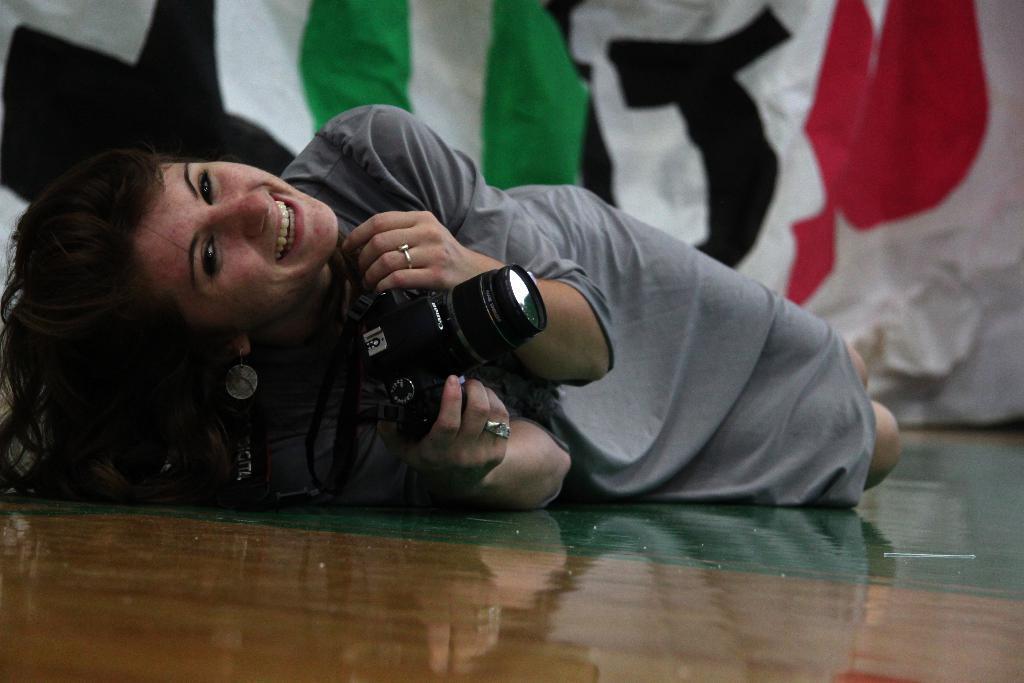Describe this image in one or two sentences. In this image I can see a person lying on the floor and holding the camera. At the back there is a banner. 